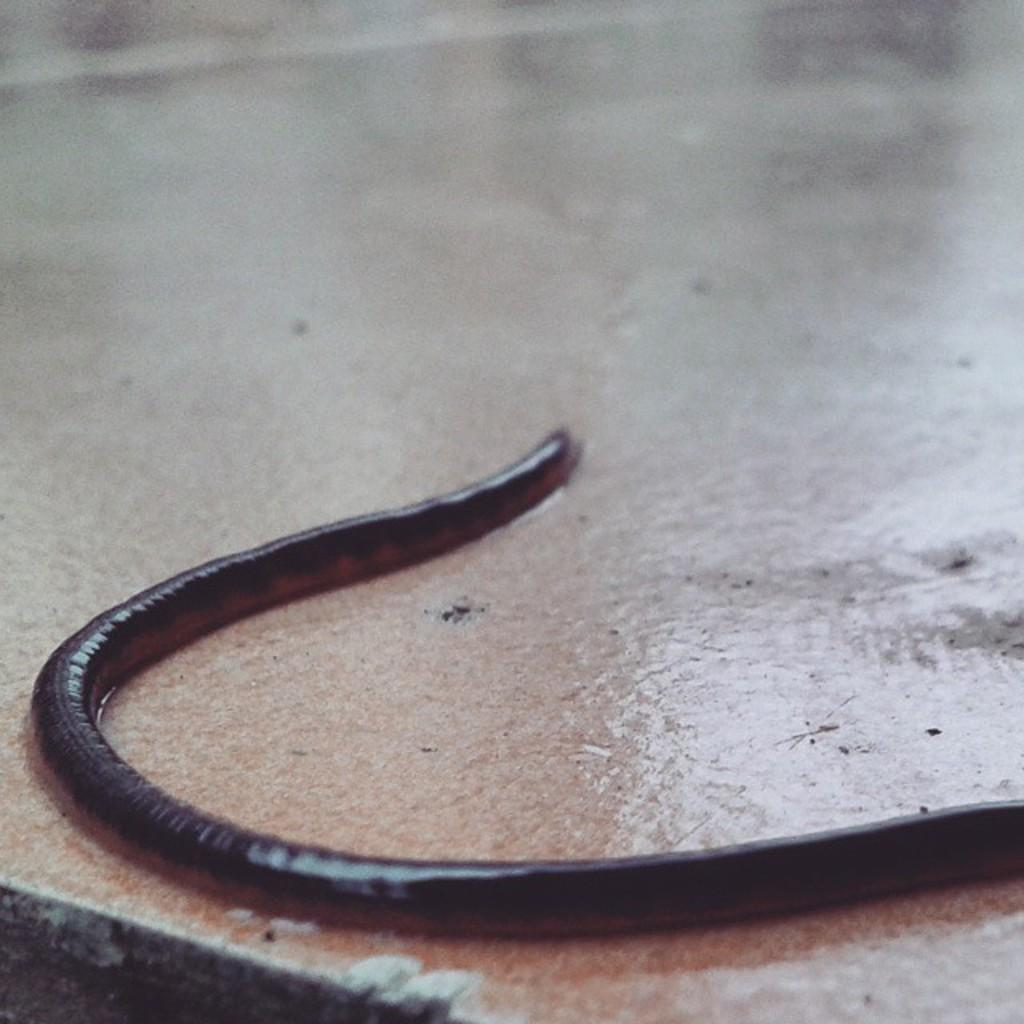What can be inferred about the temperature of the ground or path in the image? The ground or path in the image appears warm. What type of breakfast is being served on the warm ground in the image? There is no mention of breakfast or any food items in the image; the fact only states that the ground or path appears warm. 